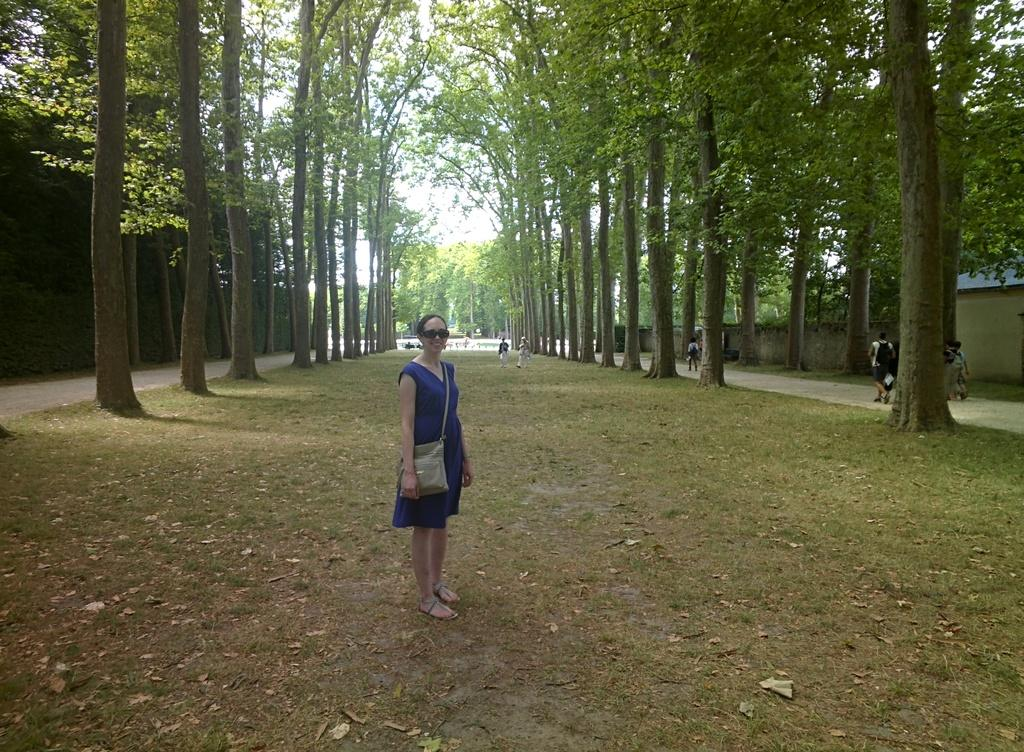What is the person standing on in the image? The person is standing on green grass in the image. Where are the other people located in the image? There are people on the walkway on the right side of the image. Is there another walkway visible in the image? Yes, there is a walkway on the left side of the image. What type of natural elements can be seen in the image? Trees are visible in the image. What type of appliance is being used to clean the waste on the walkway? There is no appliance or waste present in the image; it only features people, walkways, and trees. 